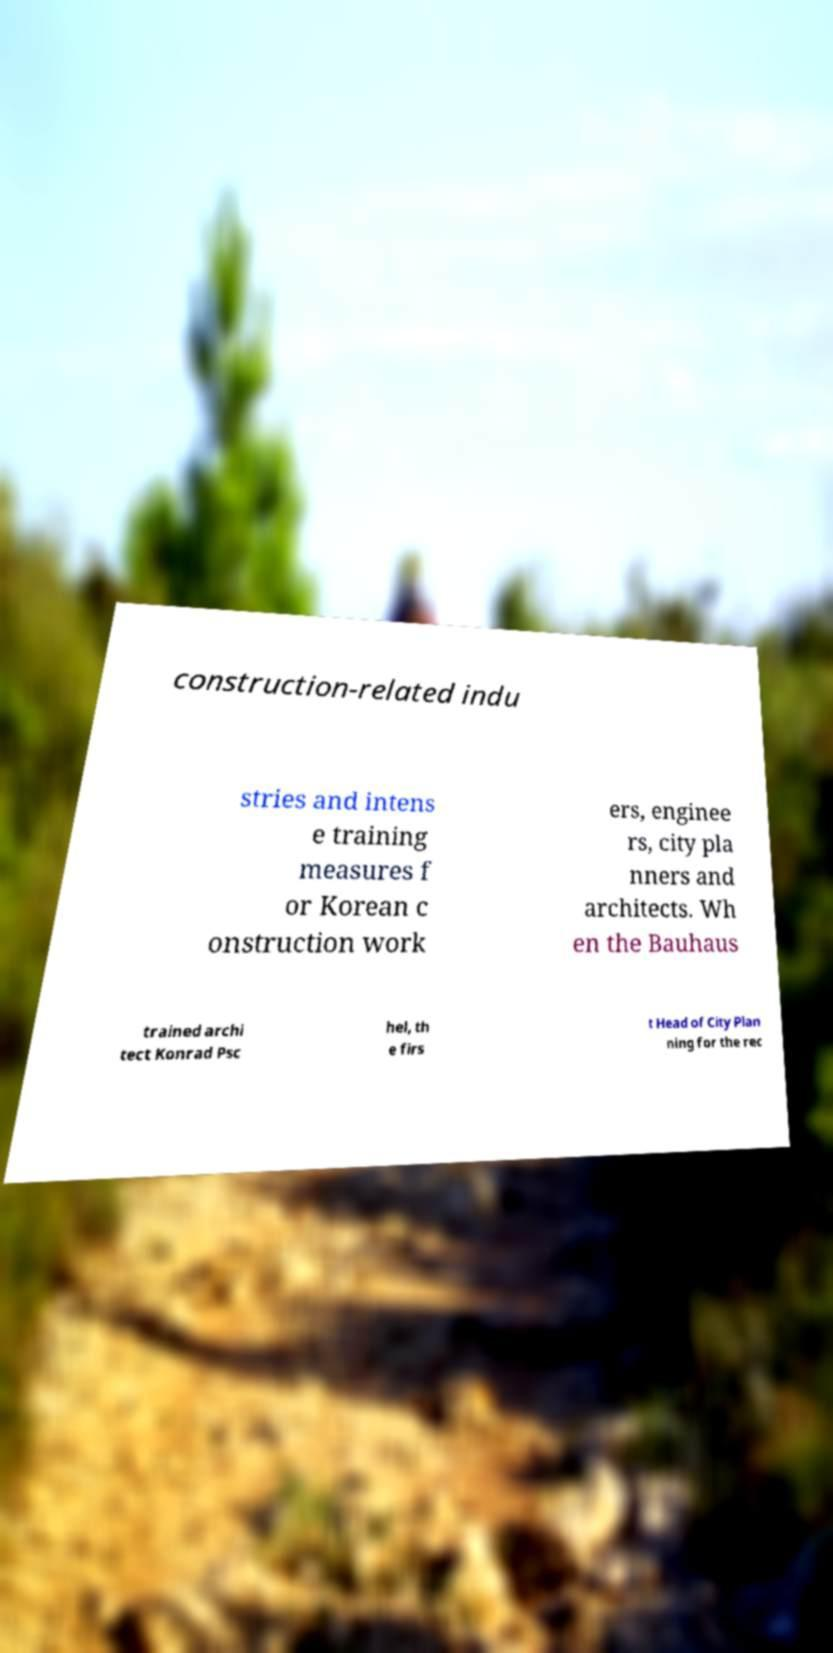For documentation purposes, I need the text within this image transcribed. Could you provide that? construction-related indu stries and intens e training measures f or Korean c onstruction work ers, enginee rs, city pla nners and architects. Wh en the Bauhaus trained archi tect Konrad Psc hel, th e firs t Head of City Plan ning for the rec 